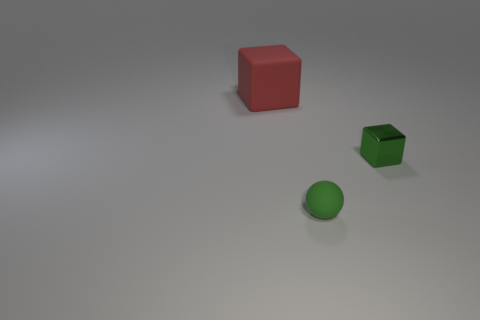Imagine if these objects could interact, what might they say to each other? If these objects could interact, I imagine the red cube might be a grounded protector, saying to the green sphere, 'Roll to me if you ever feel lost.' The green sphere, full of wanderlust, might reply, 'But there's so much to see!' Meanwhile, the small green metal cube might chime in with, 'I may be small, but I'm strong and resilient.' It's a fun way to personify the objects and give them character. 